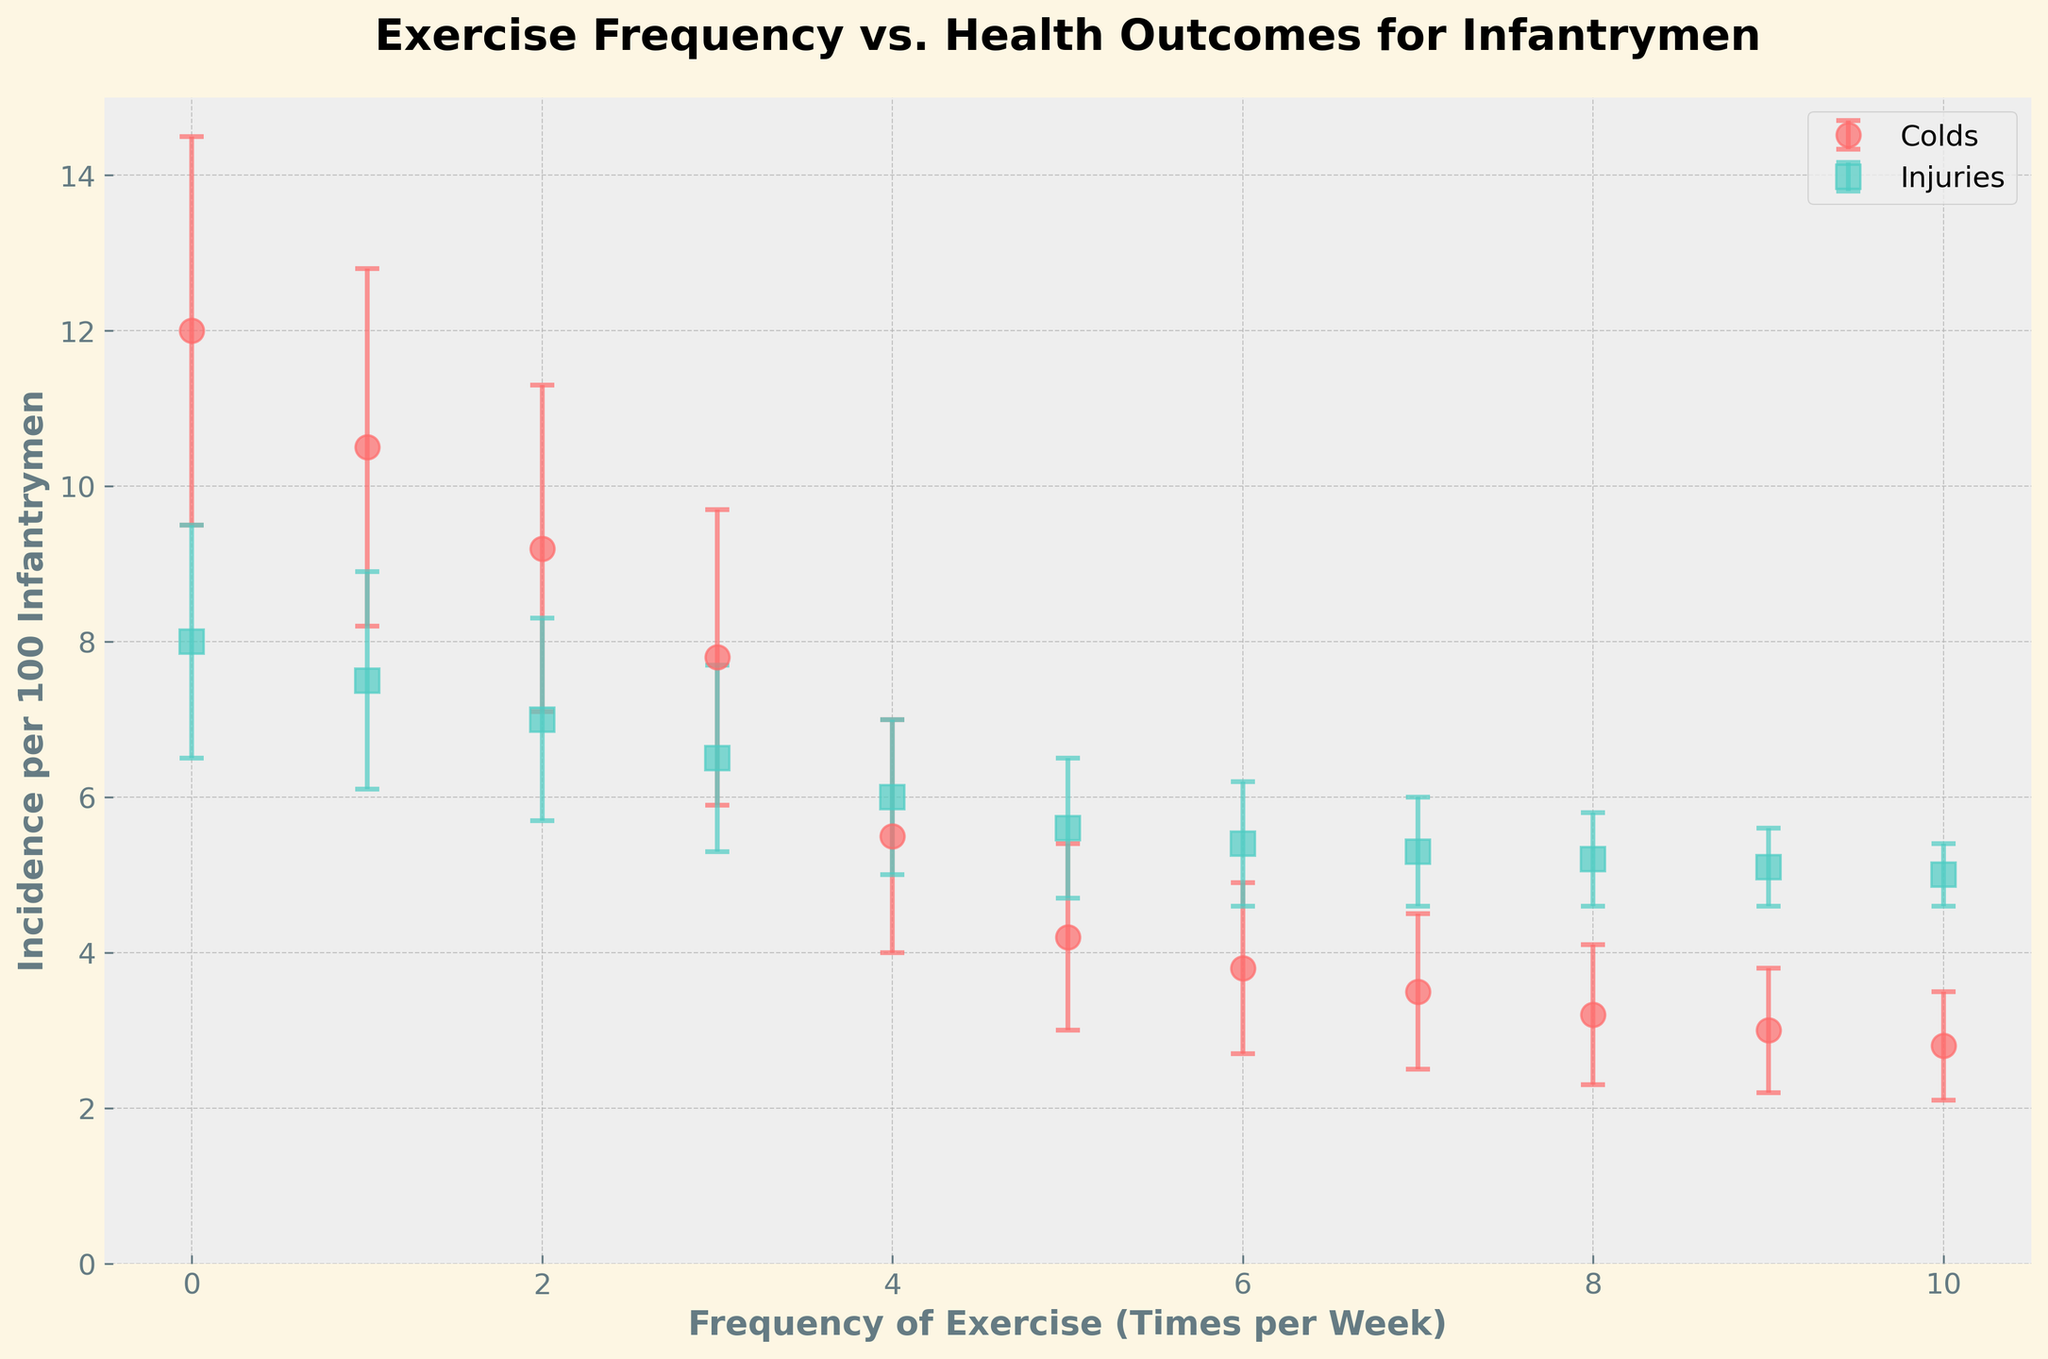what is the title of the figure? The title of the figure is located at the top of the plot. Reading it directly shows that the title is "Exercise Frequency vs. Health Outcomes for Infantrymen."
Answer: Exercise Frequency vs. Health Outcomes for Infantrymen What does the x-axis represent? The x-axis is labeled "Frequency of Exercise (Times per Week)," indicating the number of times per week that infantrymen engage in exercise.
Answer: Frequency of Exercise (Times per Week) At what exercise frequency do colds have the highest incidence? The red circles represent "Colds." The highest y-value among these points is at the leftmost point of the x-axis, where exercise frequency is 0.
Answer: 0 How do the incidences of injuries change with increased exercise frequency? As the exercise frequency increases, the incidence of injuries, represented by the green squares, shows a gradual decrease as seen from the downward trend in the plot. There is no sudden drop, but a consistent decline.
Answer: They decrease Which has a greater overall reduction when exercise frequency increases, colds or injuries? To compare, observe both trends. Colds (red circles) go from 12 to 2.8, a reduction of 9.2. Injuries (green squares) go from 8 to 5, a reduction of 3. The reduction in colds is greater.
Answer: Colds What is the incidence of colds when the frequency of exercise is 5 times per week? Follow the plot along the x-axis to the point where exercise frequency is 5 and observe the corresponding incidence on the y-axis for colds (red circles). It is at 4.2.
Answer: 4.2 At an exercise frequency of 7, what is the error margin for injuries? Locate the exercise frequency of 7 on the x-axis, find the corresponding point for injuries (green squares), and look at the error bar. The error margin listed for 7 is 0.7.
Answer: 0.7 Between which exercise frequencies do colds show the most significant drop in incidence? Compare the heights of the red circles. The biggest drop by visual inspection occurs between exercise frequencies of 3 and 4, where the incidence goes from 7.8 to 5.5.
Answer: Between 3 and 4 What is the difference in the incidence of colds between frequency 0 and frequency 10? Find the y-values for the incidences at frequency 0 (12) and frequency 10 (2.8) and calculate the difference. 12 - 2.8 = 9.2
Answer: 9.2 When the exercise frequency is 2, which health outcome (colds or injuries) has a higher incidence? Locate the points where exercise frequency is 2 on the x-axis. Compare the y-values for colds (red circles) and injuries (green squares). The y-value for colds is higher (9.2 vs 7).
Answer: Colds 